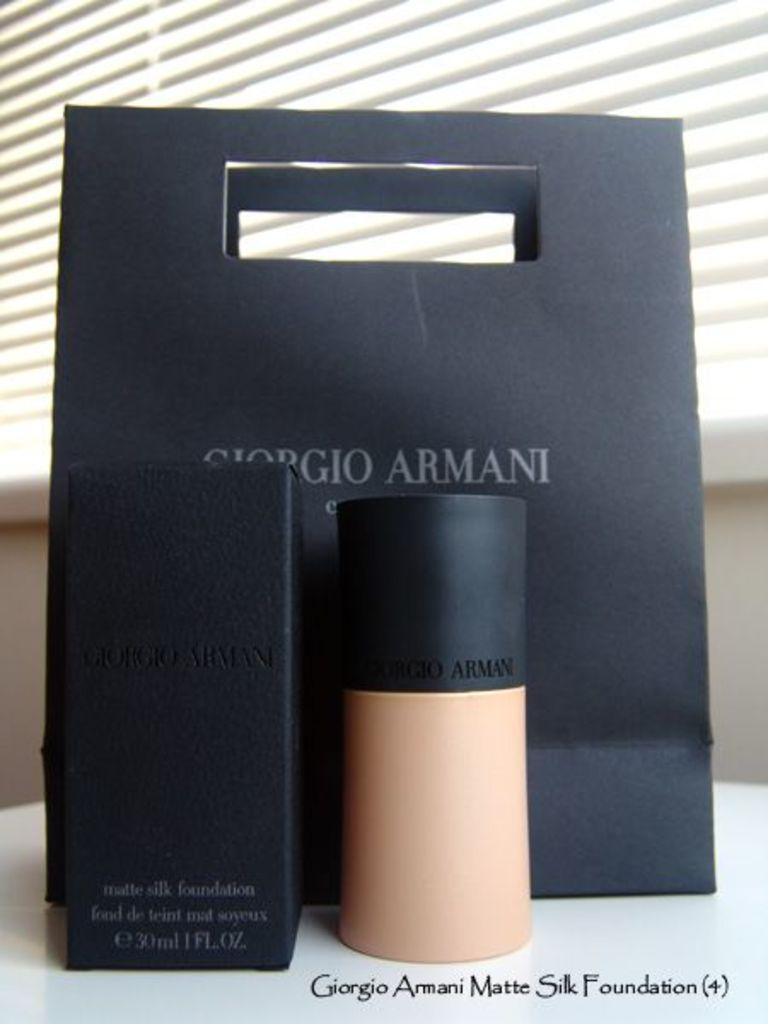What kind of makeup is this?
Provide a succinct answer. Giorgio armani. 